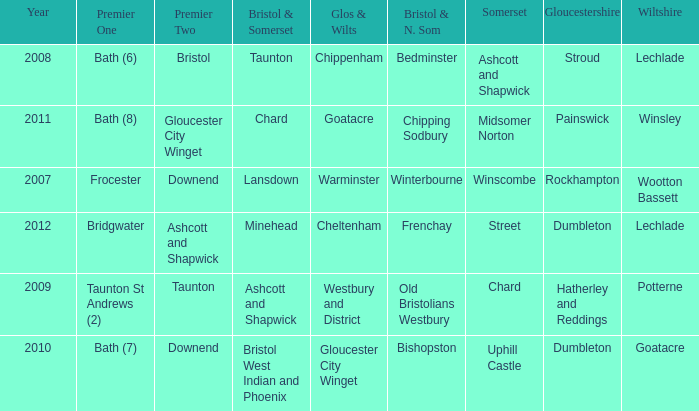What is the glos & wilts where the bristol & somerset is lansdown? Warminster. 